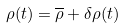Convert formula to latex. <formula><loc_0><loc_0><loc_500><loc_500>\rho ( t ) = \overline { \rho } + \delta \rho ( t )</formula> 